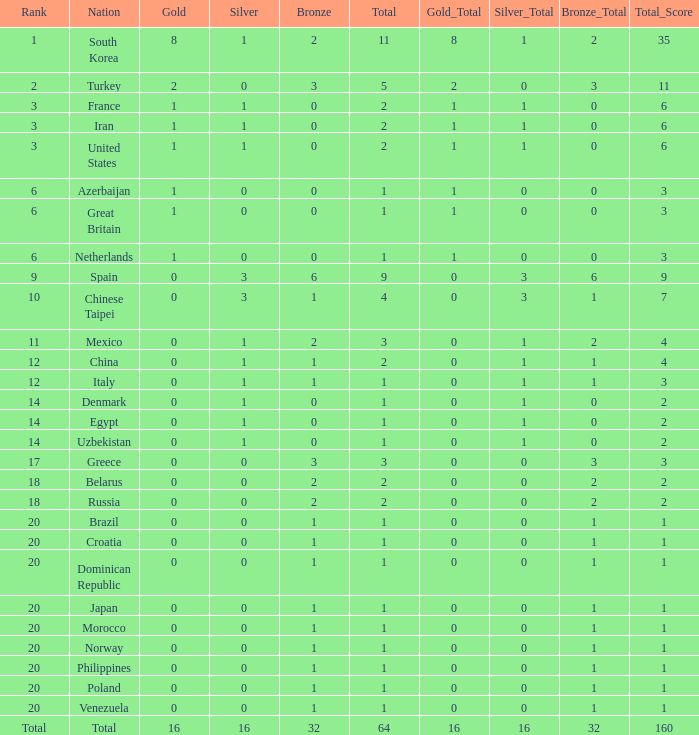What is the lowest number of gold medals the nation with less than 0 silver medals has? None. 